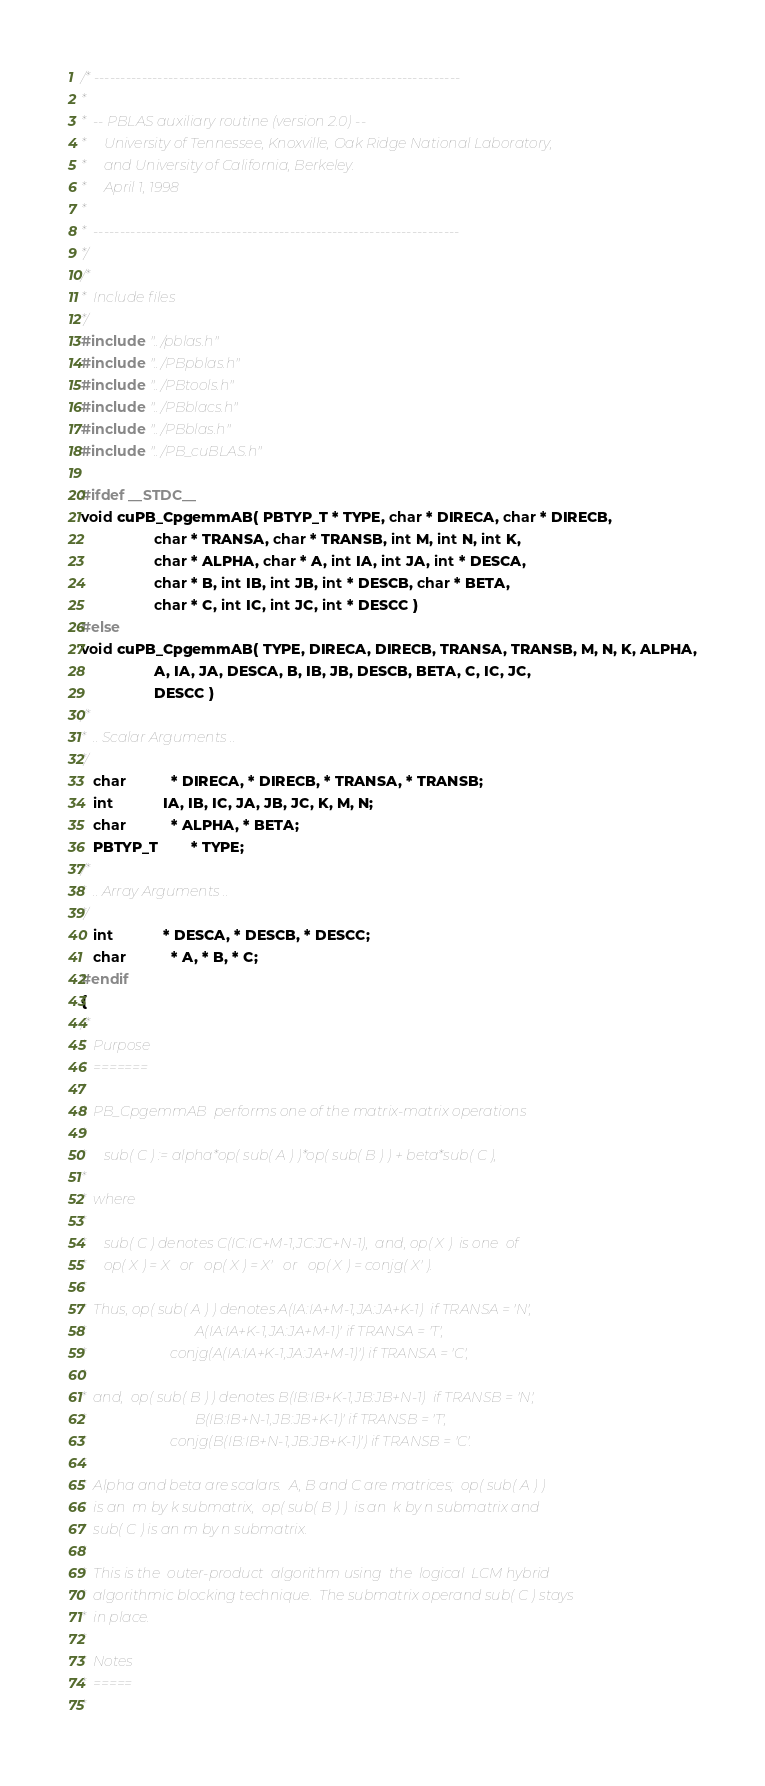<code> <loc_0><loc_0><loc_500><loc_500><_C_>/* ---------------------------------------------------------------------
*
*  -- PBLAS auxiliary routine (version 2.0) --
*     University of Tennessee, Knoxville, Oak Ridge National Laboratory,
*     and University of California, Berkeley.
*     April 1, 1998
*
*  ---------------------------------------------------------------------
*/
/*
*  Include files
*/
#include "../pblas.h"
#include "../PBpblas.h"
#include "../PBtools.h"
#include "../PBblacs.h"
#include "../PBblas.h"
#include "../PB_cuBLAS.h"

#ifdef __STDC__
void cuPB_CpgemmAB( PBTYP_T * TYPE, char * DIRECA, char * DIRECB,
                  char * TRANSA, char * TRANSB, int M, int N, int K,
                  char * ALPHA, char * A, int IA, int JA, int * DESCA,
                  char * B, int IB, int JB, int * DESCB, char * BETA,
                  char * C, int IC, int JC, int * DESCC )
#else
void cuPB_CpgemmAB( TYPE, DIRECA, DIRECB, TRANSA, TRANSB, M, N, K, ALPHA,
                  A, IA, JA, DESCA, B, IB, JB, DESCB, BETA, C, IC, JC,
                  DESCC )
/*
*  .. Scalar Arguments ..
*/
   char           * DIRECA, * DIRECB, * TRANSA, * TRANSB;
   int            IA, IB, IC, JA, JB, JC, K, M, N;
   char           * ALPHA, * BETA;
   PBTYP_T        * TYPE;
/*
*  .. Array Arguments ..
*/
   int            * DESCA, * DESCB, * DESCC;
   char           * A, * B, * C;
#endif
{
/*
*  Purpose
*  =======
*
*  PB_CpgemmAB  performs one of the matrix-matrix operations
*
*     sub( C ) := alpha*op( sub( A ) )*op( sub( B ) ) + beta*sub( C ),
*
*  where
*
*     sub( C ) denotes C(IC:IC+M-1,JC:JC+N-1),  and, op( X )  is one  of
*     op( X ) = X   or   op( X ) = X'   or   op( X ) = conjg( X' ).
*
*  Thus, op( sub( A ) ) denotes A(IA:IA+M-1,JA:JA+K-1)  if TRANSA = 'N',
*                               A(IA:IA+K-1,JA:JA+M-1)' if TRANSA = 'T',
*                        conjg(A(IA:IA+K-1,JA:JA+M-1)') if TRANSA = 'C',
*
*  and,  op( sub( B ) ) denotes B(IB:IB+K-1,JB:JB+N-1)  if TRANSB = 'N',
*                               B(IB:IB+N-1,JB:JB+K-1)' if TRANSB = 'T',
*                        conjg(B(IB:IB+N-1,JB:JB+K-1)') if TRANSB = 'C'.
*
*  Alpha and beta are scalars.  A, B and C are matrices;  op( sub( A ) )
*  is an  m by k submatrix,  op( sub( B ) )  is an  k by n submatrix and
*  sub( C ) is an m by n submatrix.
*
*  This is the  outer-product  algorithm using  the  logical  LCM hybrid
*  algorithmic blocking technique.  The submatrix operand sub( C ) stays
*  in place.
*
*  Notes
*  =====
*</code> 